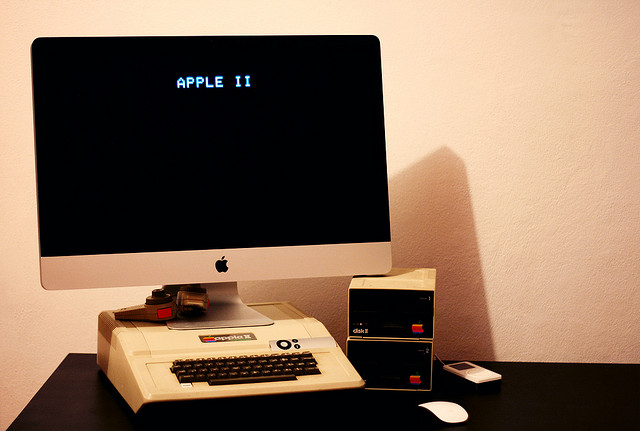Read all the text in this image. APPLE II 